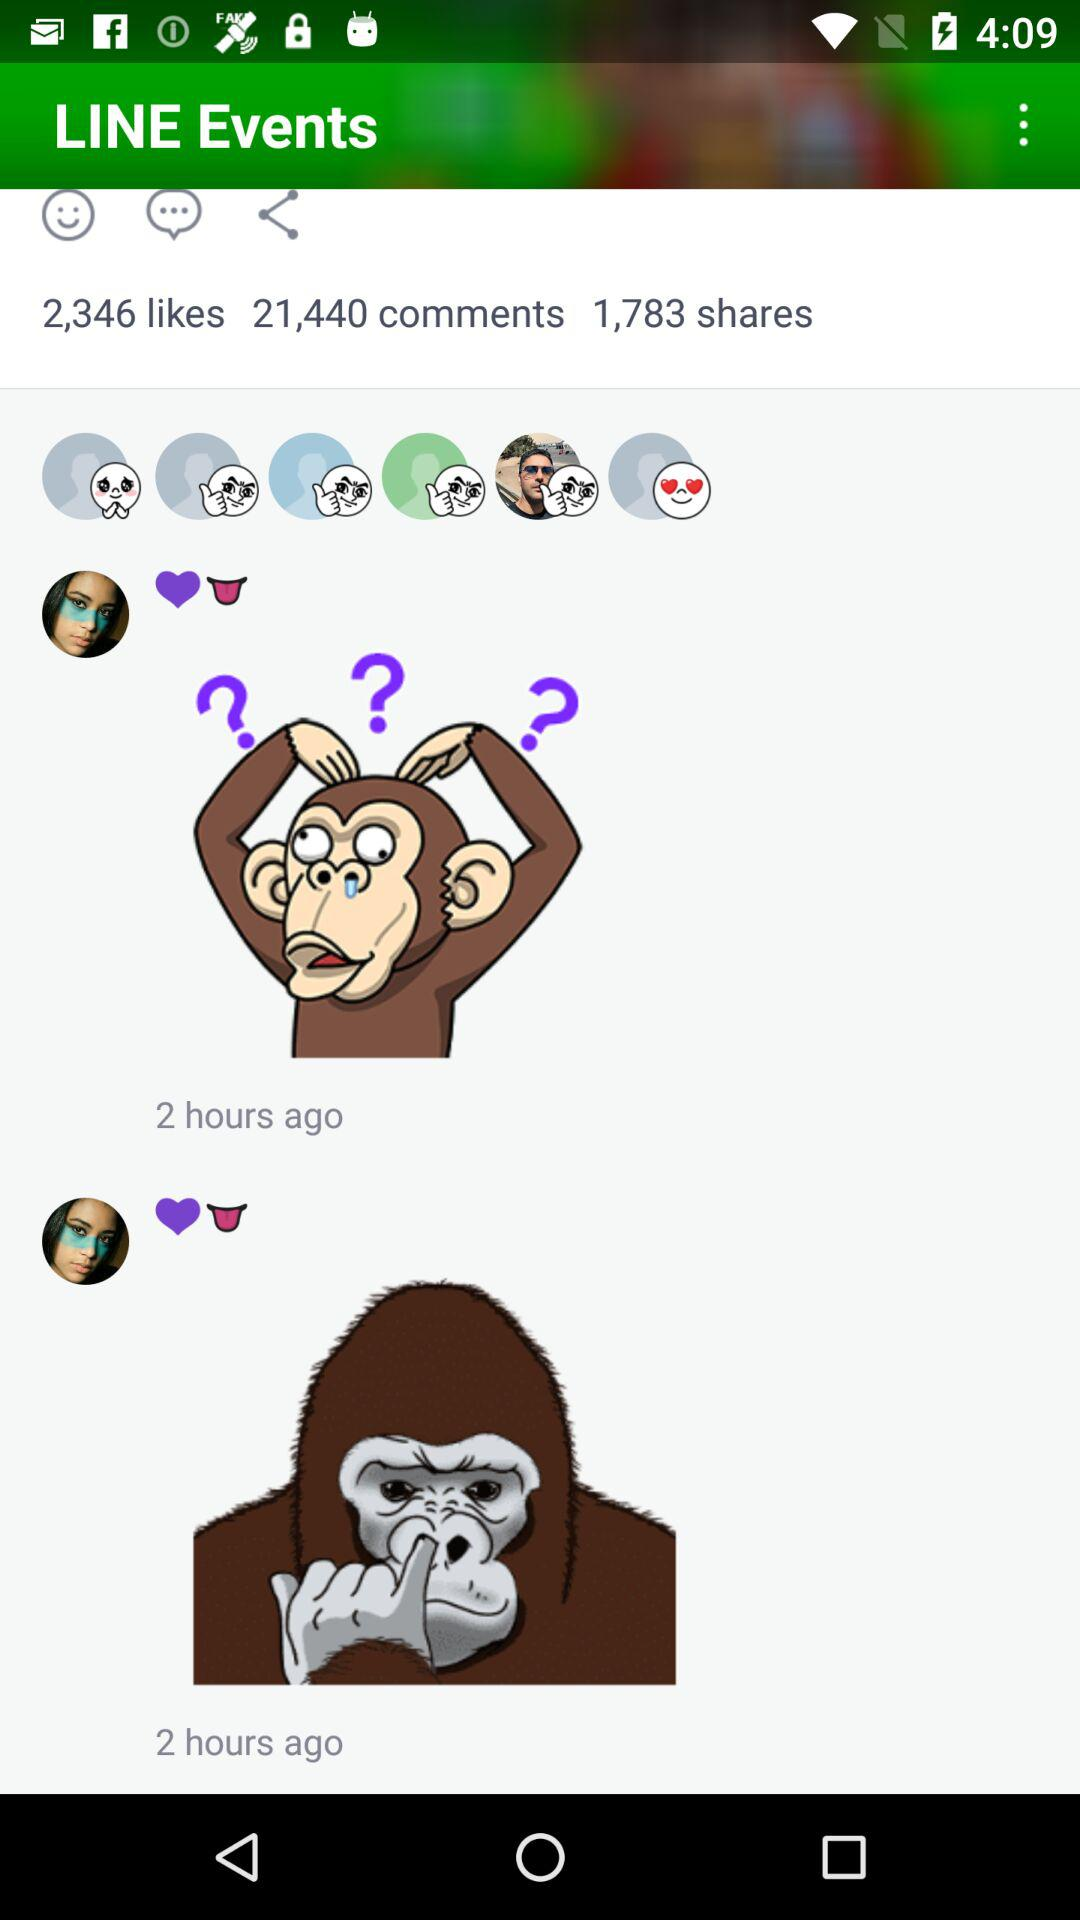How many shares are there? There are 1,783 shares. 